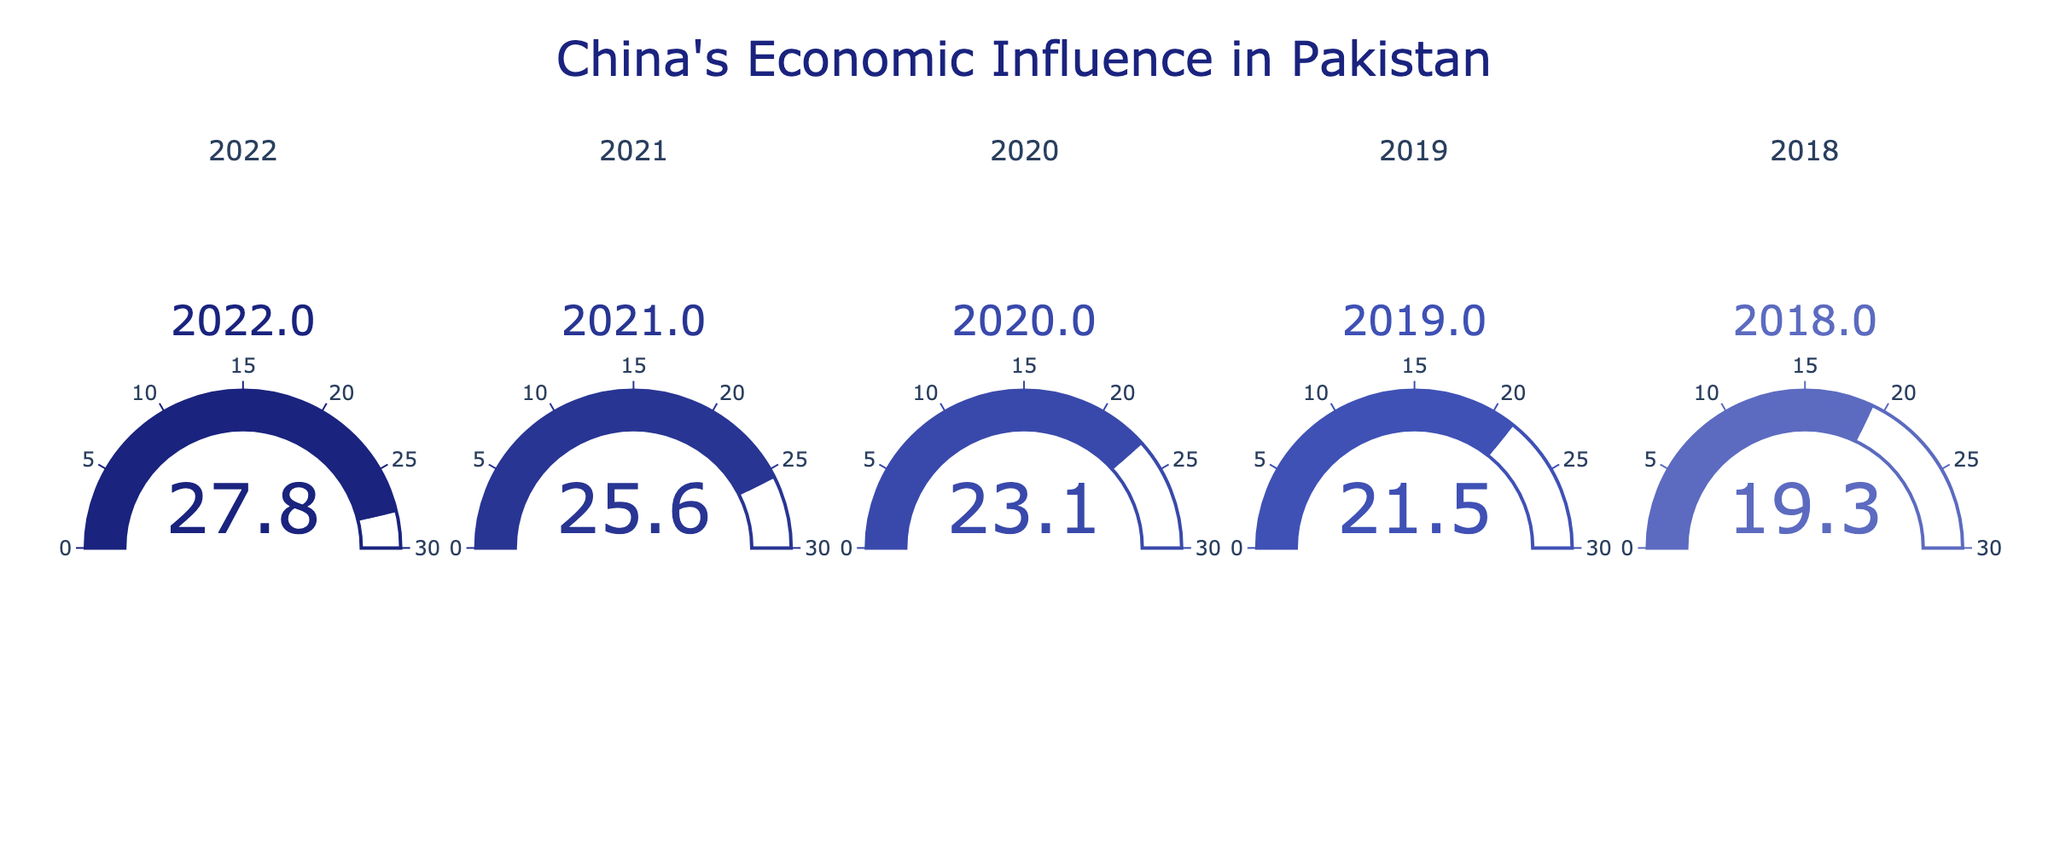what is the title of the gauge chart? The title of the gauge chart is located at the top center of the figure. It reads "China's Economic Influence in Pakistan".
Answer: China's Economic Influence in Pakistan how many years of data are represented in the gauge chart? The gauge chart displays data for five different years, which can be seen from the titles above each gauge. The years are 2018, 2019, 2020, 2021, and 2022.
Answer: 5 what was the percentage of total foreign investment from China in 2020? The percentage for each year is displayed within the gauge itself. The gauge for the year 2020 shows a value of 23.1%.
Answer: 23.1% which year had the lowest percentage of total foreign investment from China? By observing the values in the gauges, 2018 shows the lowest percentage, which is 19.3%.
Answer: 2018 what is the difference in percentage of total foreign investment from China between 2019 and 2021? To find the difference, subtract the 2019 percentage (21.5%) from the 2021 percentage (25.6%): 25.6% - 21.5% = 4.1%.
Answer: 4.1% what is the trend in the percentage of total foreign investment from China from 2018 to 2022? From 2018 to 2022, the percentages progressively increase year by year as seen on the gauges: 19.3% in 2018, 21.5% in 2019, 23.1% in 2020, 25.6% in 2021, and 27.8% in 2022.
Answer: Increasing did the percentage of total foreign investment from China ever decrease between any two consecutive years? Reviewing the data from each year, there is no decrease in any of the consecutive years from 2018 to 2022. The percentage increases every year.
Answer: No what is the average percentage of total foreign investment from China over the five years? To find the average, sum the percentages for each year and divide by the number of years: (19.3 + 21.5 + 23.1 + 25.6 + 27.8) / 5 = 23.46%.
Answer: 23.46% how much did the percentage of total foreign investment from China increase from 2018 to 2022? To find the increase, subtract the 2018 percentage (19.3%) from the 2022 percentage (27.8%): 27.8% - 19.3% = 8.5%.
Answer: 8.5% 